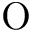Convert formula to latex. <formula><loc_0><loc_0><loc_500><loc_500>O</formula> 